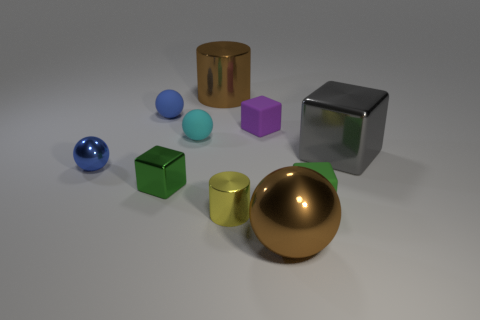Are there fewer tiny yellow metallic objects that are on the left side of the tiny cyan rubber object than metallic cubes that are behind the tiny blue shiny ball?
Give a very brief answer. Yes. There is a thing that is the same color as the big cylinder; what is its material?
Your response must be concise. Metal. What material is the tiny blue sphere that is behind the gray metal block?
Your answer should be very brief. Rubber. Are there any other things that are the same size as the purple matte block?
Provide a succinct answer. Yes. There is a small cylinder; are there any big objects right of it?
Your answer should be very brief. Yes. The small purple matte thing has what shape?
Keep it short and to the point. Cube. What number of objects are either yellow metal things that are in front of the cyan rubber ball or tiny brown metal blocks?
Keep it short and to the point. 1. How many other things are there of the same color as the large sphere?
Provide a short and direct response. 1. Do the large metallic cylinder and the large shiny object that is in front of the blue metallic ball have the same color?
Your answer should be very brief. Yes. What is the color of the other big thing that is the same shape as the yellow metal object?
Your answer should be very brief. Brown. 